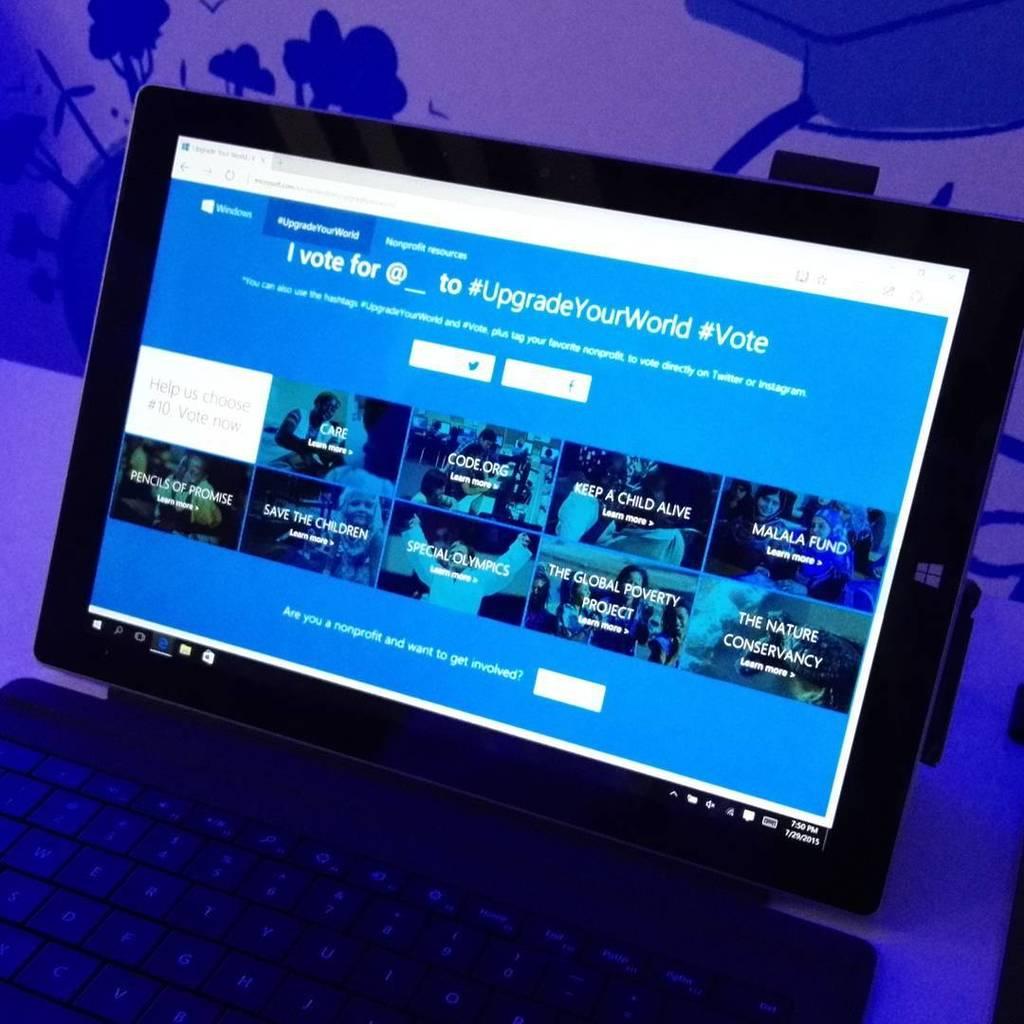What is the second hashtag?
Your answer should be very brief. #vote. 